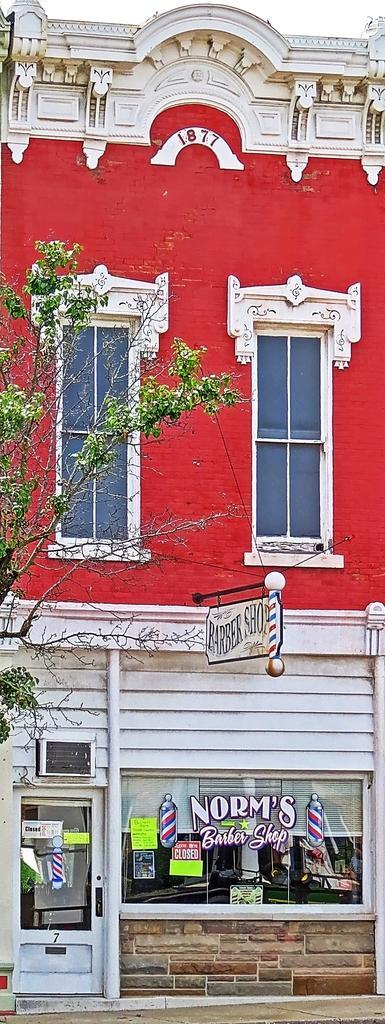Could you give a brief overview of what you see in this image? In the image we can see there is a building and there is a tree. 